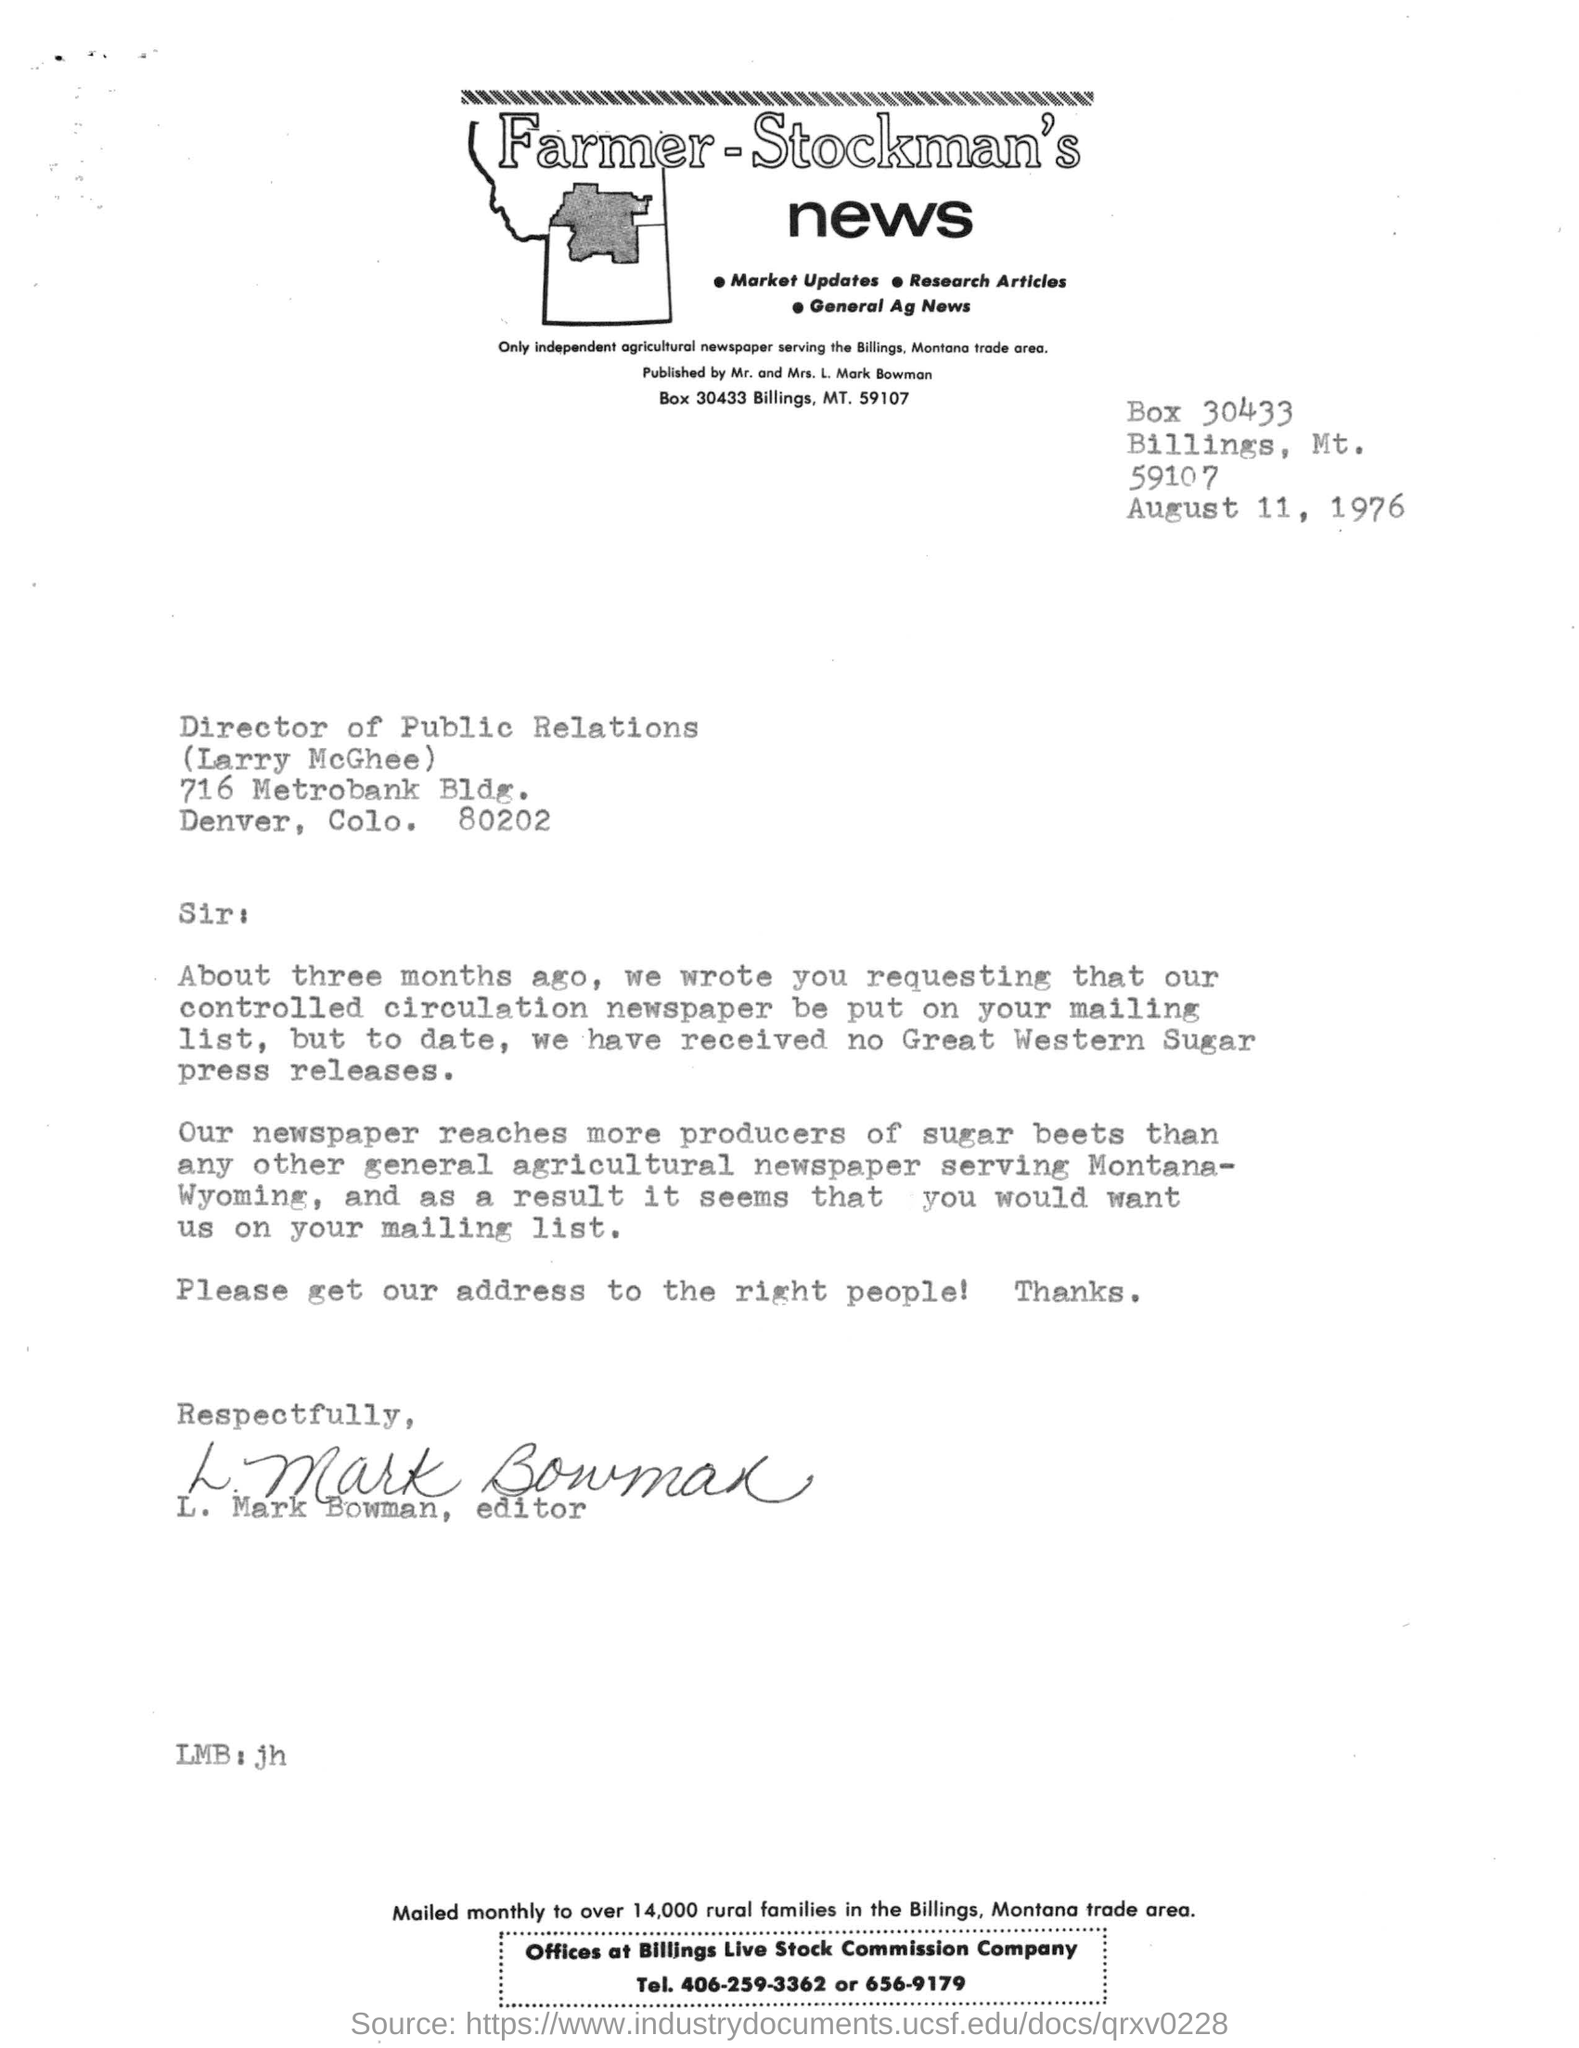Highlight a few significant elements in this photo. The publisher mentioned in the letterhead is L. Mark Bowman. The receiver of the letter is Larry McGhee. The sender of the letter is Mark Bowman. The letter mentions a date of August 11, 1976. 